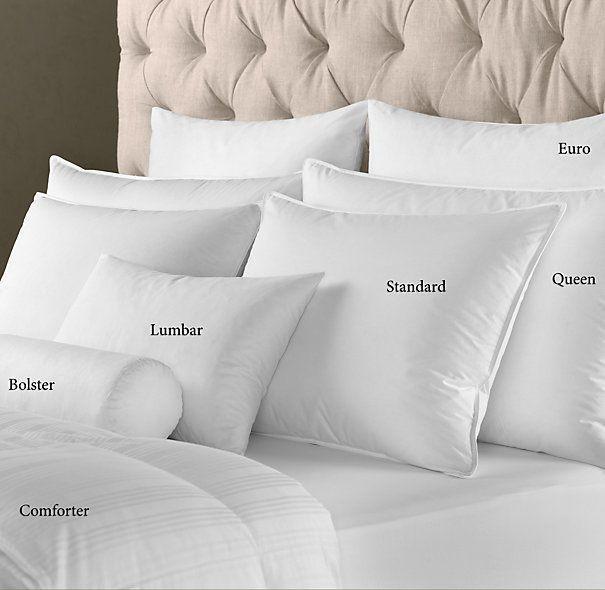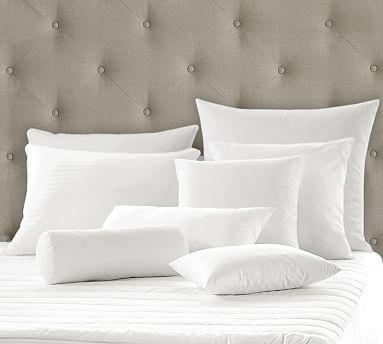The first image is the image on the left, the second image is the image on the right. Analyze the images presented: Is the assertion "White pillows are arranged in front of an upholstered headboard in at least one image." valid? Answer yes or no. Yes. 